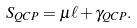Convert formula to latex. <formula><loc_0><loc_0><loc_500><loc_500>S _ { Q C P } = \mu \ell + \gamma _ { Q C P } .</formula> 